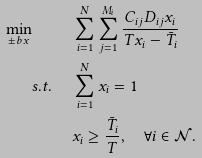Convert formula to latex. <formula><loc_0><loc_0><loc_500><loc_500>\min _ { \pm b x } \, \quad & \sum _ { i = 1 } ^ { N } \sum _ { j = 1 } ^ { M _ { i } } \frac { C _ { i j } D _ { i j } x _ { i } } { T x _ { i } - \bar { T } _ { i } } \\ s . t . \quad \, & \sum _ { i = 1 } ^ { N } x _ { i } = 1 \\ & x _ { i } \geq \frac { \bar { T } _ { i } } { T } , \quad \forall i \in \mathcal { N } .</formula> 